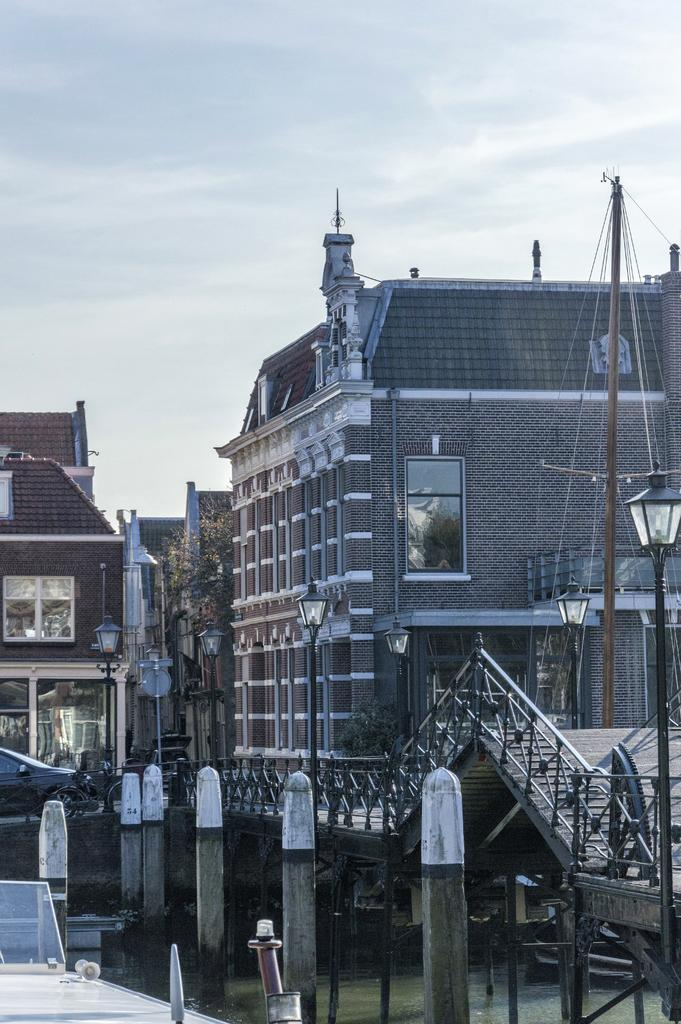What is visible in the image? Water is visible in the image. What can be seen in the background? There are light poles, stairs, and buildings in brown and gray colors in the background. Are there any specific features of the buildings? Yes, there are glass windows visible on the buildings. How would you describe the sky in the image? The sky appears to be white in color. Can you see any kitties playing with dinosaurs in the yard in the image? There are no kitties, dinosaurs, or yards present in the image. 